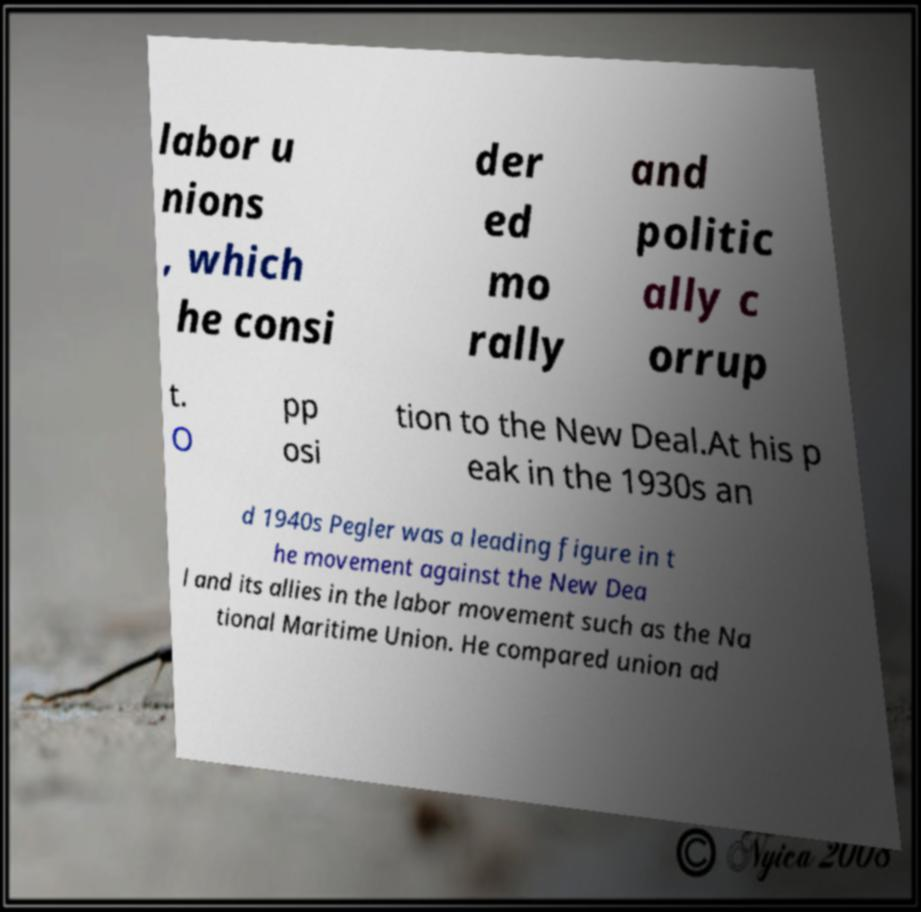What messages or text are displayed in this image? I need them in a readable, typed format. labor u nions , which he consi der ed mo rally and politic ally c orrup t. O pp osi tion to the New Deal.At his p eak in the 1930s an d 1940s Pegler was a leading figure in t he movement against the New Dea l and its allies in the labor movement such as the Na tional Maritime Union. He compared union ad 